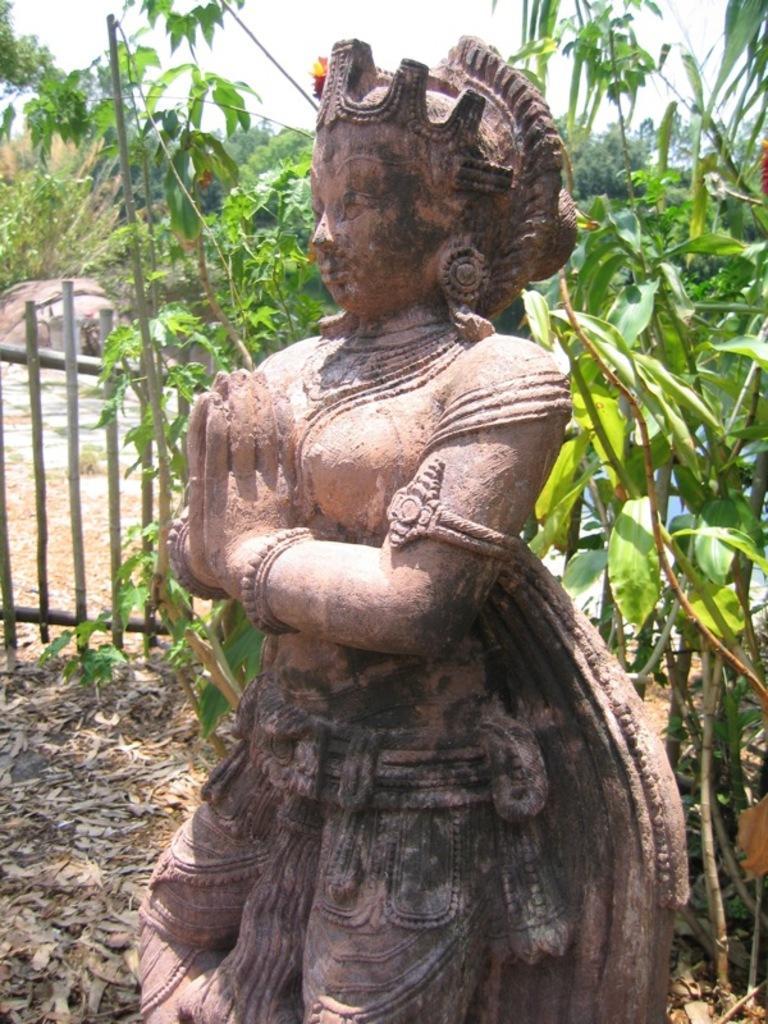Please provide a concise description of this image. In this image there is a statue, behind the statue there are plants and a wooden fence. In the background there are trees and the sky. 